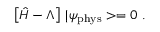Convert formula to latex. <formula><loc_0><loc_0><loc_500><loc_500>\left [ \hat { H } - \Lambda \right ] \, | \psi _ { p h y s } > = 0 \ .</formula> 